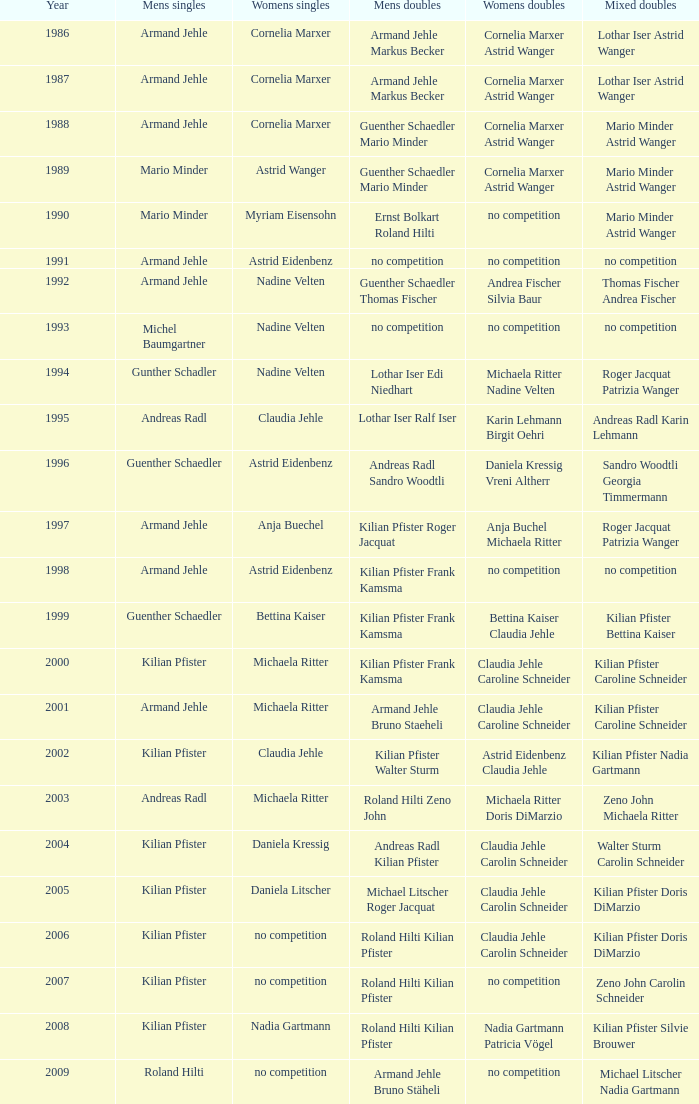What is the most current year where the women's doubles champions are astrid eidenbenz claudia jehle 2002.0. 